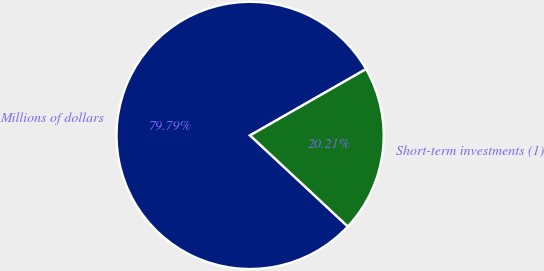Convert chart to OTSL. <chart><loc_0><loc_0><loc_500><loc_500><pie_chart><fcel>Millions of dollars<fcel>Short-term investments (1)<nl><fcel>79.79%<fcel>20.21%<nl></chart> 